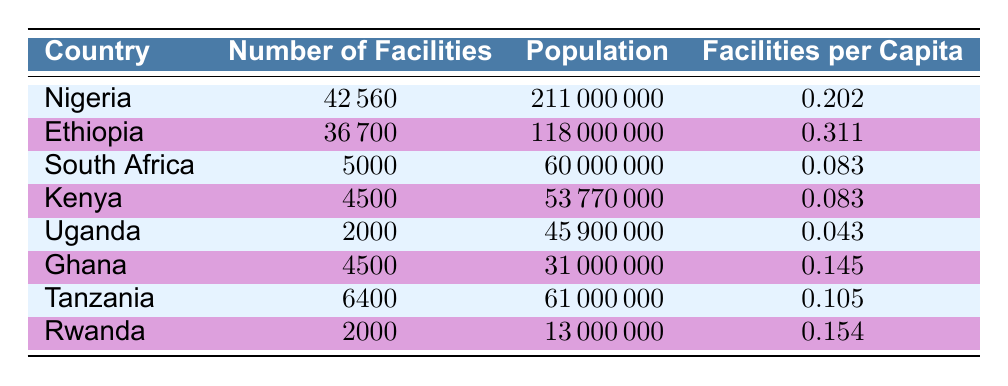What is the number of healthcare facilities in Nigeria? The table lists Nigeria with a number of facilities as 42560.
Answer: 42560 How many healthcare facilities does Ethiopia have compared to Uganda? Ethiopia has 36700 facilities while Uganda has 2000 facilities. The difference is calculated as 36700 - 2000 = 34700.
Answer: 34700 Which country has the highest number of healthcare facilities per capita? The facilities per capita for each country shows that Ethiopia has the highest rate at 0.311 compared to others, the next highest being Nigeria at 0.202.
Answer: Ethiopia Is the number of healthcare facilities in South Africa greater than in Kenya? The table shows South Africa has 5000 facilities and Kenya has 4500 facilities. Since 5000 > 4500, the answer is Yes.
Answer: Yes What is the average number of healthcare facilities per capita for the listed countries? Summing the per capita values: 0.202 (Nigeria) + 0.311 (Ethiopia) + 0.083 (South Africa) + 0.083 (Kenya) + 0.043 (Uganda) + 0.145 (Ghana) + 0.105 (Tanzania) + 0.154 (Rwanda) = 1.126. Dividing by the number of countries (8): 1.126/8 = 0.14075.
Answer: 0.14075 Which country’s facilities per capita is closest to 0.1? The closest value to 0.1 is Tanzania, with a facility per capita of 0.105, which is the smallest difference from 0.1 when compared to others.
Answer: Tanzania Is it true that Ghana has more healthcare facilities per capita than Uganda? In the table, Ghana has 0.145 per capita and Uganda has 0.043. Thus, 0.145 > 0.043, making the statement true.
Answer: Yes What is the total number of healthcare facilities across all the listed countries? The total is 42560 (Nigeria) + 36700 (Ethiopia) + 5000 (South Africa) + 4500 (Kenya) + 2000 (Uganda) + 4500 (Ghana) + 6400 (Tanzania) + 2000 (Rwanda) = 60160.
Answer: 60160 